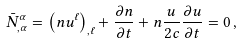Convert formula to latex. <formula><loc_0><loc_0><loc_500><loc_500>\bar { N } _ { , \alpha } ^ { \alpha } = \left ( n u ^ { \ell } \right ) _ { , \ell } + \frac { \partial n } { \partial t } + n \frac { u } { 2 c } \frac { \partial u } { \partial t } = 0 \, ,</formula> 